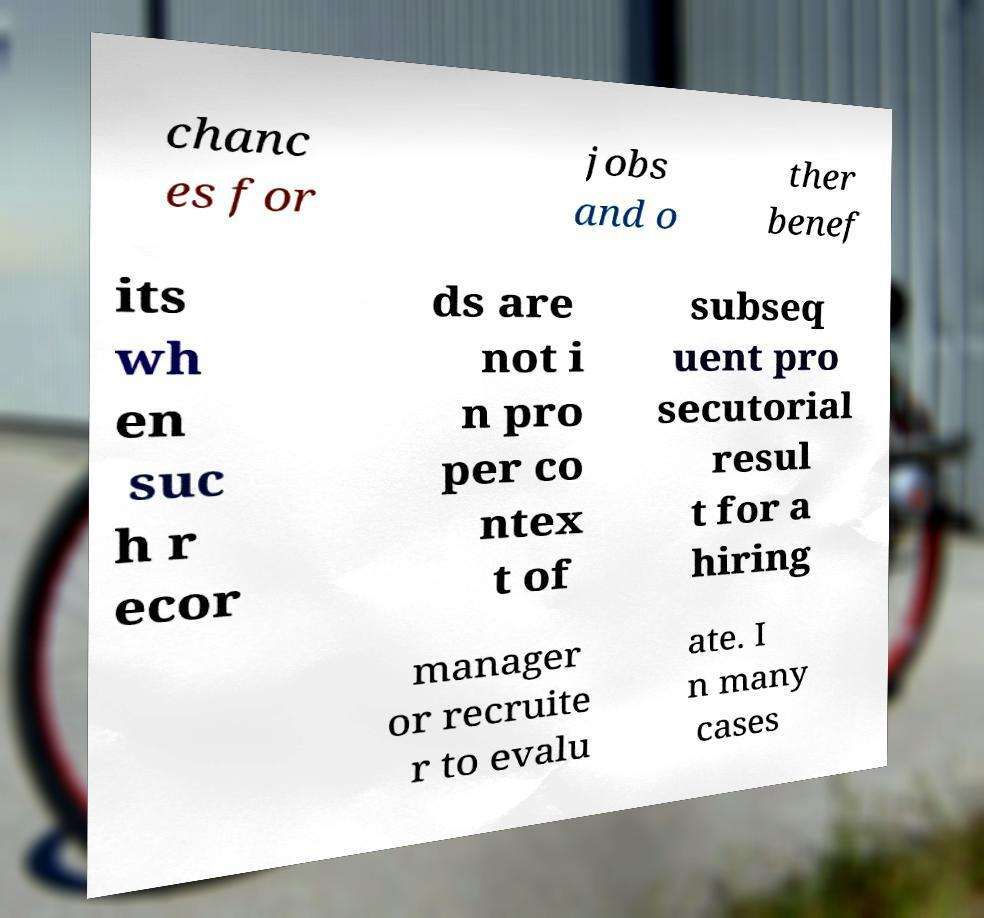I need the written content from this picture converted into text. Can you do that? chanc es for jobs and o ther benef its wh en suc h r ecor ds are not i n pro per co ntex t of subseq uent pro secutorial resul t for a hiring manager or recruite r to evalu ate. I n many cases 